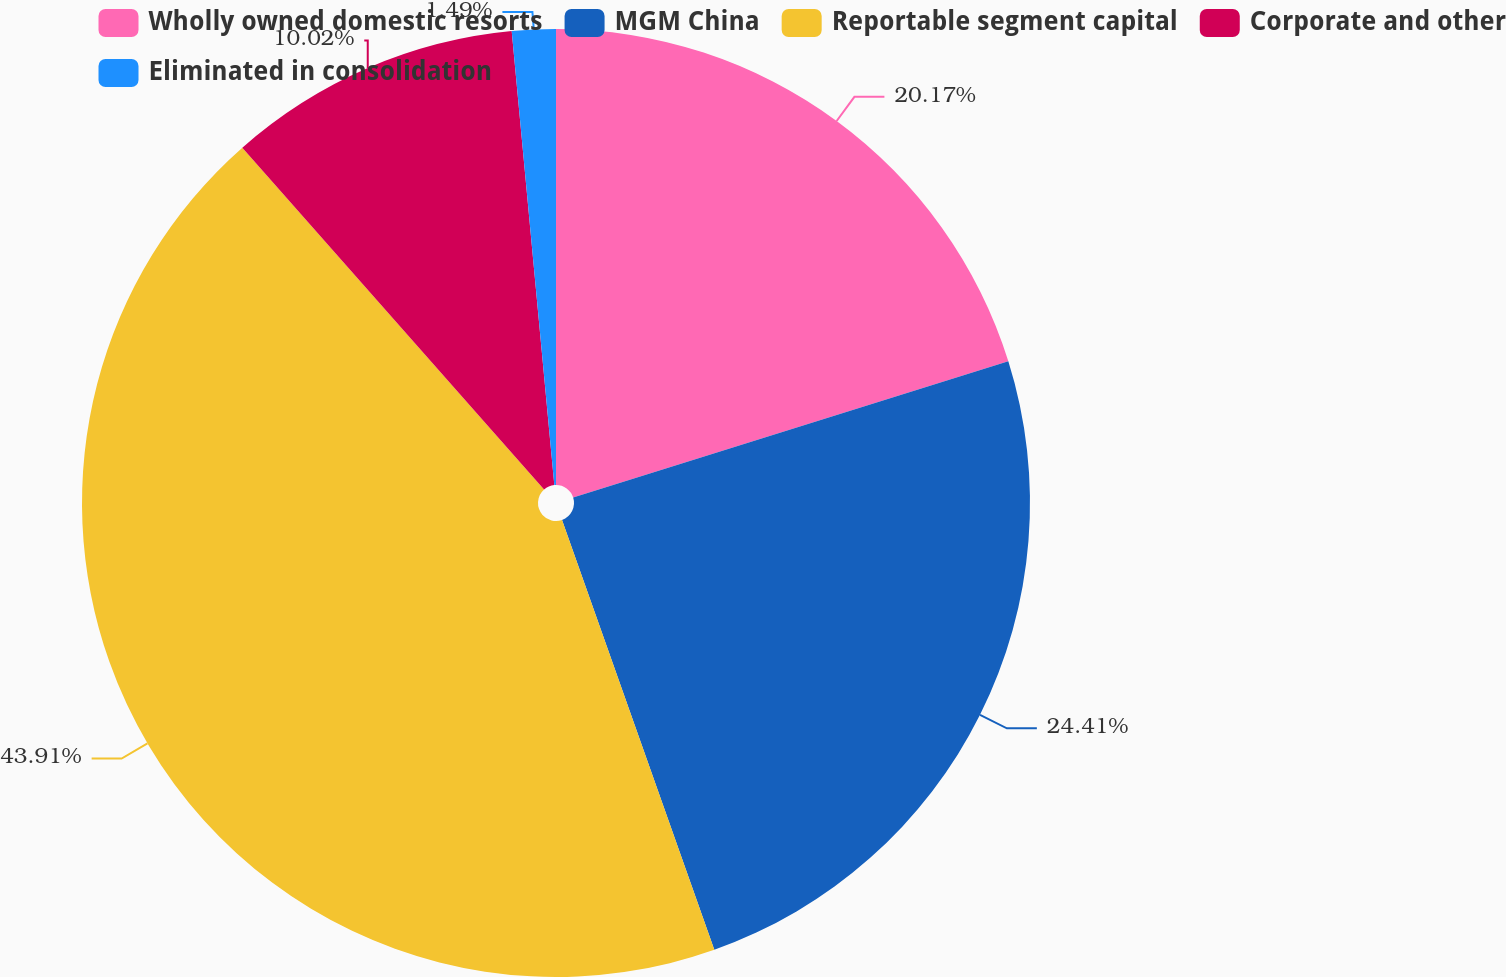Convert chart. <chart><loc_0><loc_0><loc_500><loc_500><pie_chart><fcel>Wholly owned domestic resorts<fcel>MGM China<fcel>Reportable segment capital<fcel>Corporate and other<fcel>Eliminated in consolidation<nl><fcel>20.17%<fcel>24.41%<fcel>43.91%<fcel>10.02%<fcel>1.49%<nl></chart> 